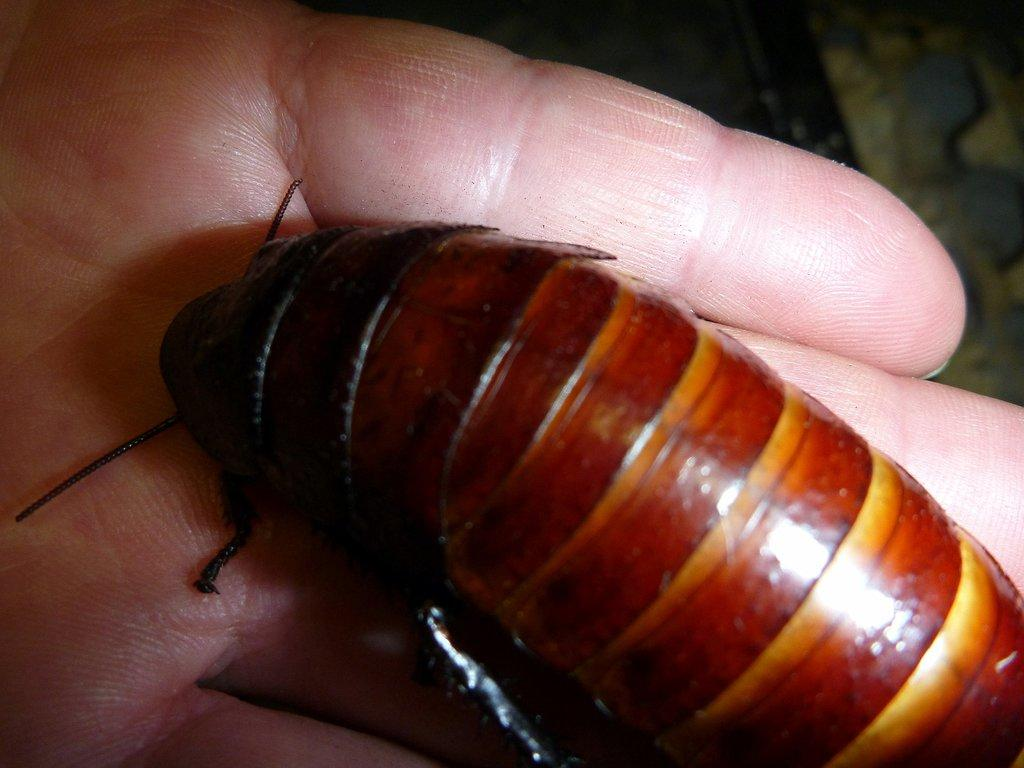What is present on the person's hand in the image? There is an insect on the person's hand in the image. Can you describe the insect in the image? Unfortunately, the facts provided do not give any details about the insect's appearance. What can be observed about the background of the image? The background of the image is blurred. What type of flowers can be seen growing on the person's hand in the image? There are no flowers present on the person's hand in the image; it only features an insect. How many beans are visible on the person's hand in the image? There are no beans present on the person's hand in the image; it only features an insect. 